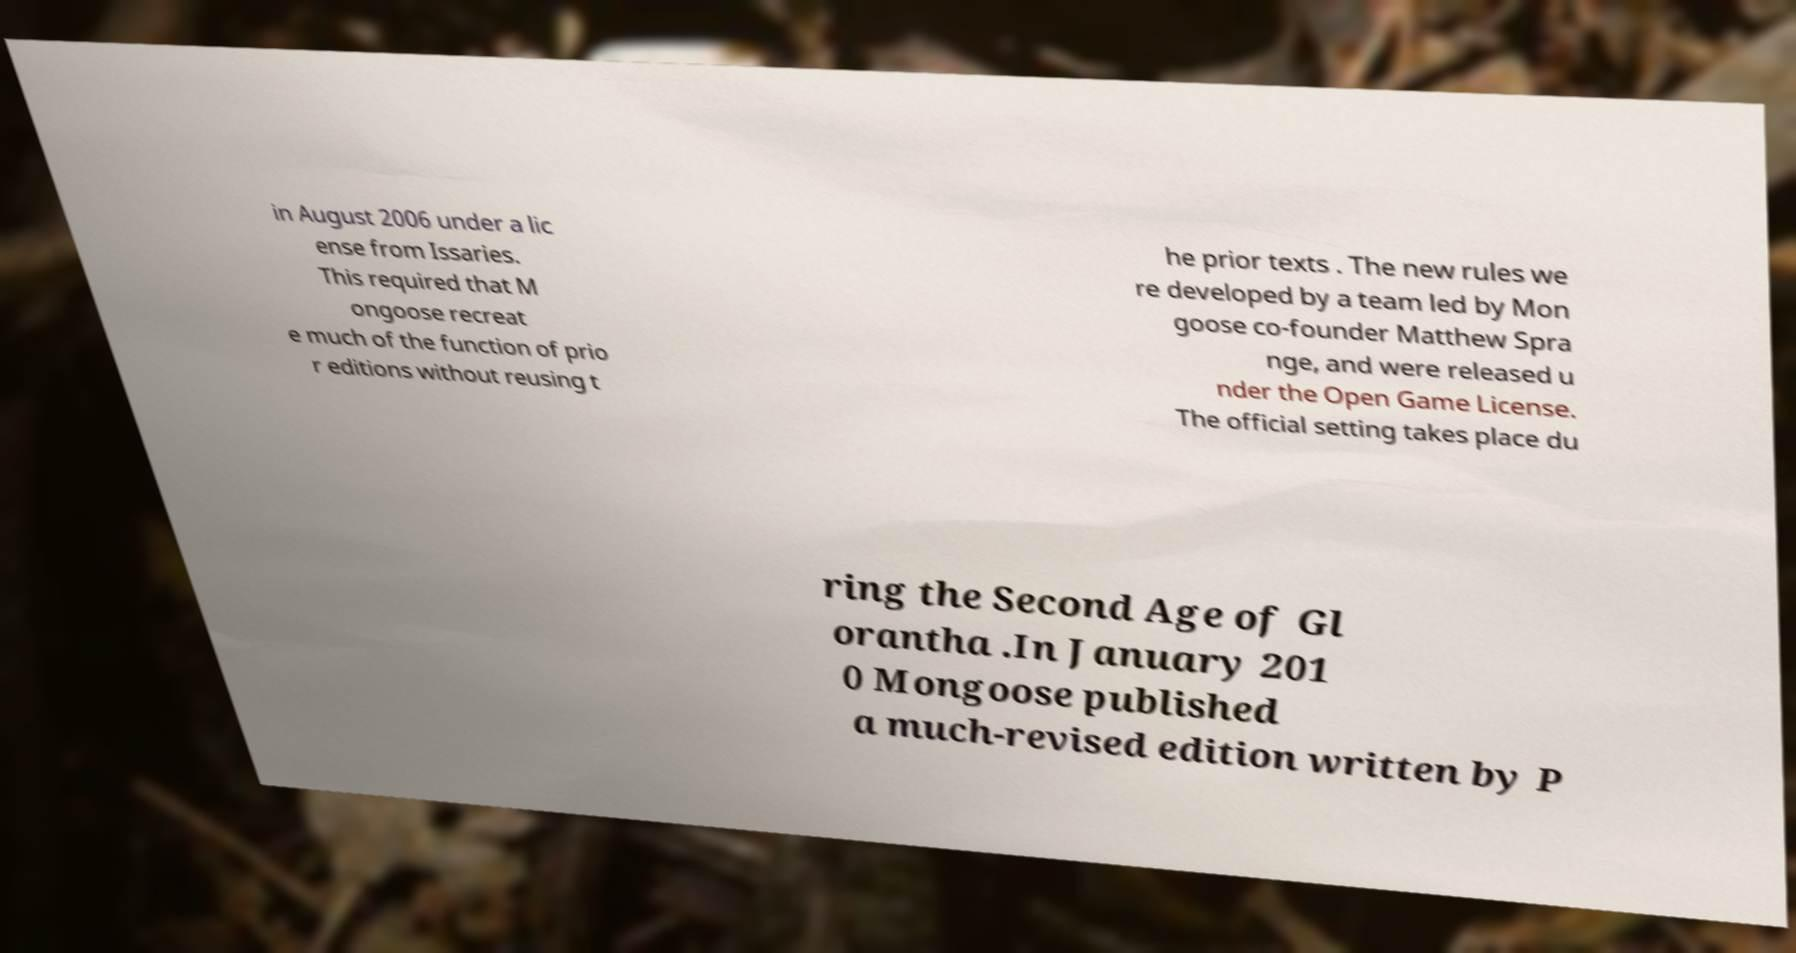Can you accurately transcribe the text from the provided image for me? in August 2006 under a lic ense from Issaries. This required that M ongoose recreat e much of the function of prio r editions without reusing t he prior texts . The new rules we re developed by a team led by Mon goose co-founder Matthew Spra nge, and were released u nder the Open Game License. The official setting takes place du ring the Second Age of Gl orantha .In January 201 0 Mongoose published a much-revised edition written by P 